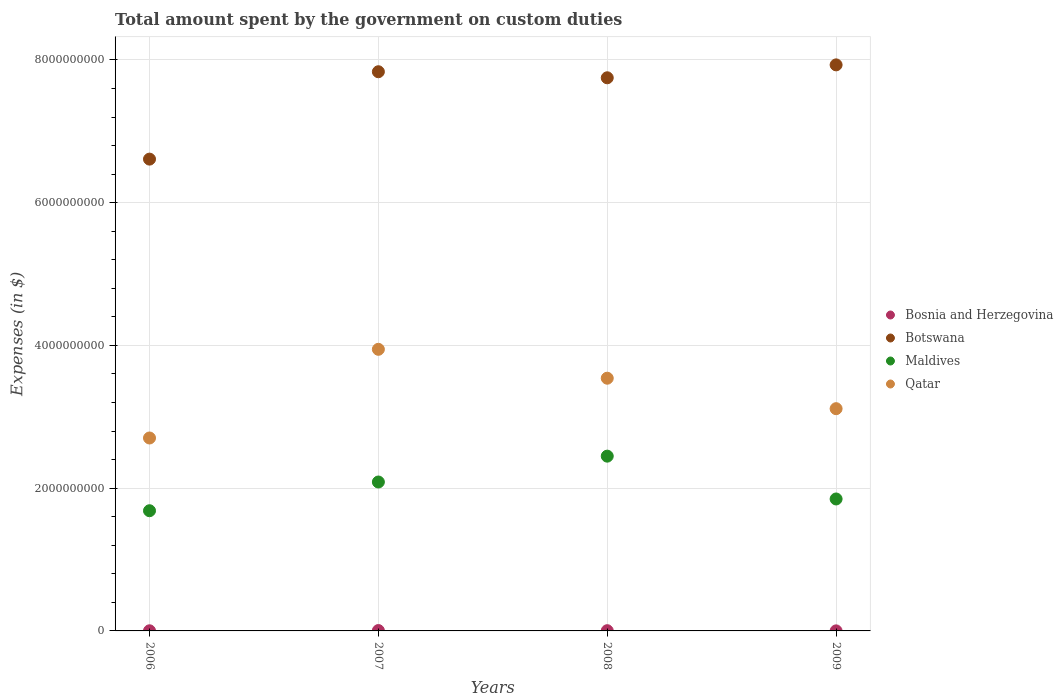Is the number of dotlines equal to the number of legend labels?
Provide a succinct answer. Yes. What is the amount spent on custom duties by the government in Qatar in 2007?
Give a very brief answer. 3.95e+09. Across all years, what is the maximum amount spent on custom duties by the government in Botswana?
Provide a succinct answer. 7.93e+09. Across all years, what is the minimum amount spent on custom duties by the government in Qatar?
Provide a short and direct response. 2.70e+09. What is the total amount spent on custom duties by the government in Qatar in the graph?
Your response must be concise. 1.33e+1. What is the difference between the amount spent on custom duties by the government in Bosnia and Herzegovina in 2006 and that in 2007?
Offer a terse response. -3.30e+06. What is the difference between the amount spent on custom duties by the government in Botswana in 2007 and the amount spent on custom duties by the government in Qatar in 2008?
Provide a short and direct response. 4.29e+09. What is the average amount spent on custom duties by the government in Maldives per year?
Keep it short and to the point. 2.02e+09. In the year 2006, what is the difference between the amount spent on custom duties by the government in Qatar and amount spent on custom duties by the government in Bosnia and Herzegovina?
Offer a terse response. 2.70e+09. What is the ratio of the amount spent on custom duties by the government in Bosnia and Herzegovina in 2006 to that in 2007?
Your answer should be very brief. 0.36. What is the difference between the highest and the second highest amount spent on custom duties by the government in Maldives?
Your answer should be very brief. 3.62e+08. What is the difference between the highest and the lowest amount spent on custom duties by the government in Qatar?
Give a very brief answer. 1.24e+09. Is it the case that in every year, the sum of the amount spent on custom duties by the government in Bosnia and Herzegovina and amount spent on custom duties by the government in Maldives  is greater than the sum of amount spent on custom duties by the government in Botswana and amount spent on custom duties by the government in Qatar?
Keep it short and to the point. Yes. Is the amount spent on custom duties by the government in Botswana strictly less than the amount spent on custom duties by the government in Qatar over the years?
Keep it short and to the point. No. How many dotlines are there?
Keep it short and to the point. 4. How many years are there in the graph?
Your response must be concise. 4. What is the difference between two consecutive major ticks on the Y-axis?
Ensure brevity in your answer.  2.00e+09. Does the graph contain any zero values?
Provide a succinct answer. No. How are the legend labels stacked?
Your answer should be very brief. Vertical. What is the title of the graph?
Ensure brevity in your answer.  Total amount spent by the government on custom duties. Does "Bosnia and Herzegovina" appear as one of the legend labels in the graph?
Your answer should be compact. Yes. What is the label or title of the Y-axis?
Ensure brevity in your answer.  Expenses (in $). What is the Expenses (in $) of Bosnia and Herzegovina in 2006?
Give a very brief answer. 1.86e+06. What is the Expenses (in $) of Botswana in 2006?
Your answer should be very brief. 6.61e+09. What is the Expenses (in $) of Maldives in 2006?
Provide a succinct answer. 1.68e+09. What is the Expenses (in $) of Qatar in 2006?
Your answer should be compact. 2.70e+09. What is the Expenses (in $) in Bosnia and Herzegovina in 2007?
Offer a very short reply. 5.15e+06. What is the Expenses (in $) in Botswana in 2007?
Keep it short and to the point. 7.83e+09. What is the Expenses (in $) in Maldives in 2007?
Offer a terse response. 2.09e+09. What is the Expenses (in $) of Qatar in 2007?
Offer a very short reply. 3.95e+09. What is the Expenses (in $) of Bosnia and Herzegovina in 2008?
Keep it short and to the point. 3.23e+06. What is the Expenses (in $) of Botswana in 2008?
Provide a succinct answer. 7.75e+09. What is the Expenses (in $) in Maldives in 2008?
Make the answer very short. 2.45e+09. What is the Expenses (in $) of Qatar in 2008?
Offer a very short reply. 3.54e+09. What is the Expenses (in $) in Bosnia and Herzegovina in 2009?
Give a very brief answer. 7.27e+05. What is the Expenses (in $) of Botswana in 2009?
Offer a terse response. 7.93e+09. What is the Expenses (in $) in Maldives in 2009?
Your response must be concise. 1.85e+09. What is the Expenses (in $) of Qatar in 2009?
Offer a very short reply. 3.11e+09. Across all years, what is the maximum Expenses (in $) of Bosnia and Herzegovina?
Offer a terse response. 5.15e+06. Across all years, what is the maximum Expenses (in $) of Botswana?
Offer a very short reply. 7.93e+09. Across all years, what is the maximum Expenses (in $) in Maldives?
Provide a succinct answer. 2.45e+09. Across all years, what is the maximum Expenses (in $) of Qatar?
Your response must be concise. 3.95e+09. Across all years, what is the minimum Expenses (in $) in Bosnia and Herzegovina?
Provide a short and direct response. 7.27e+05. Across all years, what is the minimum Expenses (in $) of Botswana?
Provide a short and direct response. 6.61e+09. Across all years, what is the minimum Expenses (in $) of Maldives?
Your answer should be very brief. 1.68e+09. Across all years, what is the minimum Expenses (in $) of Qatar?
Make the answer very short. 2.70e+09. What is the total Expenses (in $) in Bosnia and Herzegovina in the graph?
Offer a terse response. 1.10e+07. What is the total Expenses (in $) of Botswana in the graph?
Keep it short and to the point. 3.01e+1. What is the total Expenses (in $) in Maldives in the graph?
Your answer should be very brief. 8.07e+09. What is the total Expenses (in $) in Qatar in the graph?
Ensure brevity in your answer.  1.33e+1. What is the difference between the Expenses (in $) of Bosnia and Herzegovina in 2006 and that in 2007?
Make the answer very short. -3.30e+06. What is the difference between the Expenses (in $) of Botswana in 2006 and that in 2007?
Keep it short and to the point. -1.22e+09. What is the difference between the Expenses (in $) in Maldives in 2006 and that in 2007?
Your answer should be compact. -4.02e+08. What is the difference between the Expenses (in $) in Qatar in 2006 and that in 2007?
Keep it short and to the point. -1.24e+09. What is the difference between the Expenses (in $) in Bosnia and Herzegovina in 2006 and that in 2008?
Give a very brief answer. -1.38e+06. What is the difference between the Expenses (in $) in Botswana in 2006 and that in 2008?
Make the answer very short. -1.14e+09. What is the difference between the Expenses (in $) of Maldives in 2006 and that in 2008?
Your response must be concise. -7.65e+08. What is the difference between the Expenses (in $) in Qatar in 2006 and that in 2008?
Make the answer very short. -8.38e+08. What is the difference between the Expenses (in $) in Bosnia and Herzegovina in 2006 and that in 2009?
Ensure brevity in your answer.  1.13e+06. What is the difference between the Expenses (in $) in Botswana in 2006 and that in 2009?
Provide a short and direct response. -1.32e+09. What is the difference between the Expenses (in $) in Maldives in 2006 and that in 2009?
Provide a short and direct response. -1.65e+08. What is the difference between the Expenses (in $) in Qatar in 2006 and that in 2009?
Give a very brief answer. -4.11e+08. What is the difference between the Expenses (in $) of Bosnia and Herzegovina in 2007 and that in 2008?
Keep it short and to the point. 1.92e+06. What is the difference between the Expenses (in $) of Botswana in 2007 and that in 2008?
Give a very brief answer. 8.47e+07. What is the difference between the Expenses (in $) of Maldives in 2007 and that in 2008?
Your answer should be very brief. -3.62e+08. What is the difference between the Expenses (in $) in Qatar in 2007 and that in 2008?
Offer a terse response. 4.05e+08. What is the difference between the Expenses (in $) of Bosnia and Herzegovina in 2007 and that in 2009?
Provide a short and direct response. 4.43e+06. What is the difference between the Expenses (in $) of Botswana in 2007 and that in 2009?
Make the answer very short. -9.62e+07. What is the difference between the Expenses (in $) in Maldives in 2007 and that in 2009?
Offer a very short reply. 2.38e+08. What is the difference between the Expenses (in $) in Qatar in 2007 and that in 2009?
Keep it short and to the point. 8.32e+08. What is the difference between the Expenses (in $) in Bosnia and Herzegovina in 2008 and that in 2009?
Your answer should be very brief. 2.51e+06. What is the difference between the Expenses (in $) in Botswana in 2008 and that in 2009?
Your answer should be compact. -1.81e+08. What is the difference between the Expenses (in $) in Maldives in 2008 and that in 2009?
Provide a succinct answer. 6.00e+08. What is the difference between the Expenses (in $) of Qatar in 2008 and that in 2009?
Make the answer very short. 4.27e+08. What is the difference between the Expenses (in $) in Bosnia and Herzegovina in 2006 and the Expenses (in $) in Botswana in 2007?
Your answer should be compact. -7.83e+09. What is the difference between the Expenses (in $) of Bosnia and Herzegovina in 2006 and the Expenses (in $) of Maldives in 2007?
Your answer should be compact. -2.08e+09. What is the difference between the Expenses (in $) of Bosnia and Herzegovina in 2006 and the Expenses (in $) of Qatar in 2007?
Keep it short and to the point. -3.94e+09. What is the difference between the Expenses (in $) in Botswana in 2006 and the Expenses (in $) in Maldives in 2007?
Give a very brief answer. 4.52e+09. What is the difference between the Expenses (in $) of Botswana in 2006 and the Expenses (in $) of Qatar in 2007?
Offer a very short reply. 2.66e+09. What is the difference between the Expenses (in $) of Maldives in 2006 and the Expenses (in $) of Qatar in 2007?
Offer a terse response. -2.26e+09. What is the difference between the Expenses (in $) of Bosnia and Herzegovina in 2006 and the Expenses (in $) of Botswana in 2008?
Provide a short and direct response. -7.75e+09. What is the difference between the Expenses (in $) of Bosnia and Herzegovina in 2006 and the Expenses (in $) of Maldives in 2008?
Your response must be concise. -2.45e+09. What is the difference between the Expenses (in $) in Bosnia and Herzegovina in 2006 and the Expenses (in $) in Qatar in 2008?
Offer a terse response. -3.54e+09. What is the difference between the Expenses (in $) of Botswana in 2006 and the Expenses (in $) of Maldives in 2008?
Your response must be concise. 4.16e+09. What is the difference between the Expenses (in $) of Botswana in 2006 and the Expenses (in $) of Qatar in 2008?
Ensure brevity in your answer.  3.07e+09. What is the difference between the Expenses (in $) in Maldives in 2006 and the Expenses (in $) in Qatar in 2008?
Ensure brevity in your answer.  -1.86e+09. What is the difference between the Expenses (in $) of Bosnia and Herzegovina in 2006 and the Expenses (in $) of Botswana in 2009?
Give a very brief answer. -7.93e+09. What is the difference between the Expenses (in $) of Bosnia and Herzegovina in 2006 and the Expenses (in $) of Maldives in 2009?
Provide a short and direct response. -1.85e+09. What is the difference between the Expenses (in $) of Bosnia and Herzegovina in 2006 and the Expenses (in $) of Qatar in 2009?
Your answer should be compact. -3.11e+09. What is the difference between the Expenses (in $) of Botswana in 2006 and the Expenses (in $) of Maldives in 2009?
Give a very brief answer. 4.76e+09. What is the difference between the Expenses (in $) in Botswana in 2006 and the Expenses (in $) in Qatar in 2009?
Offer a terse response. 3.50e+09. What is the difference between the Expenses (in $) of Maldives in 2006 and the Expenses (in $) of Qatar in 2009?
Your response must be concise. -1.43e+09. What is the difference between the Expenses (in $) in Bosnia and Herzegovina in 2007 and the Expenses (in $) in Botswana in 2008?
Ensure brevity in your answer.  -7.74e+09. What is the difference between the Expenses (in $) in Bosnia and Herzegovina in 2007 and the Expenses (in $) in Maldives in 2008?
Offer a terse response. -2.44e+09. What is the difference between the Expenses (in $) in Bosnia and Herzegovina in 2007 and the Expenses (in $) in Qatar in 2008?
Offer a terse response. -3.54e+09. What is the difference between the Expenses (in $) of Botswana in 2007 and the Expenses (in $) of Maldives in 2008?
Make the answer very short. 5.39e+09. What is the difference between the Expenses (in $) of Botswana in 2007 and the Expenses (in $) of Qatar in 2008?
Make the answer very short. 4.29e+09. What is the difference between the Expenses (in $) of Maldives in 2007 and the Expenses (in $) of Qatar in 2008?
Your response must be concise. -1.45e+09. What is the difference between the Expenses (in $) in Bosnia and Herzegovina in 2007 and the Expenses (in $) in Botswana in 2009?
Your answer should be compact. -7.93e+09. What is the difference between the Expenses (in $) in Bosnia and Herzegovina in 2007 and the Expenses (in $) in Maldives in 2009?
Your answer should be very brief. -1.84e+09. What is the difference between the Expenses (in $) in Bosnia and Herzegovina in 2007 and the Expenses (in $) in Qatar in 2009?
Ensure brevity in your answer.  -3.11e+09. What is the difference between the Expenses (in $) of Botswana in 2007 and the Expenses (in $) of Maldives in 2009?
Give a very brief answer. 5.99e+09. What is the difference between the Expenses (in $) in Botswana in 2007 and the Expenses (in $) in Qatar in 2009?
Your answer should be very brief. 4.72e+09. What is the difference between the Expenses (in $) in Maldives in 2007 and the Expenses (in $) in Qatar in 2009?
Keep it short and to the point. -1.03e+09. What is the difference between the Expenses (in $) in Bosnia and Herzegovina in 2008 and the Expenses (in $) in Botswana in 2009?
Your answer should be compact. -7.93e+09. What is the difference between the Expenses (in $) in Bosnia and Herzegovina in 2008 and the Expenses (in $) in Maldives in 2009?
Your response must be concise. -1.85e+09. What is the difference between the Expenses (in $) in Bosnia and Herzegovina in 2008 and the Expenses (in $) in Qatar in 2009?
Keep it short and to the point. -3.11e+09. What is the difference between the Expenses (in $) in Botswana in 2008 and the Expenses (in $) in Maldives in 2009?
Provide a short and direct response. 5.90e+09. What is the difference between the Expenses (in $) in Botswana in 2008 and the Expenses (in $) in Qatar in 2009?
Keep it short and to the point. 4.64e+09. What is the difference between the Expenses (in $) in Maldives in 2008 and the Expenses (in $) in Qatar in 2009?
Your response must be concise. -6.65e+08. What is the average Expenses (in $) in Bosnia and Herzegovina per year?
Your answer should be very brief. 2.74e+06. What is the average Expenses (in $) in Botswana per year?
Your answer should be compact. 7.53e+09. What is the average Expenses (in $) in Maldives per year?
Provide a succinct answer. 2.02e+09. What is the average Expenses (in $) of Qatar per year?
Ensure brevity in your answer.  3.33e+09. In the year 2006, what is the difference between the Expenses (in $) of Bosnia and Herzegovina and Expenses (in $) of Botswana?
Give a very brief answer. -6.61e+09. In the year 2006, what is the difference between the Expenses (in $) of Bosnia and Herzegovina and Expenses (in $) of Maldives?
Give a very brief answer. -1.68e+09. In the year 2006, what is the difference between the Expenses (in $) in Bosnia and Herzegovina and Expenses (in $) in Qatar?
Ensure brevity in your answer.  -2.70e+09. In the year 2006, what is the difference between the Expenses (in $) in Botswana and Expenses (in $) in Maldives?
Your answer should be very brief. 4.93e+09. In the year 2006, what is the difference between the Expenses (in $) of Botswana and Expenses (in $) of Qatar?
Make the answer very short. 3.91e+09. In the year 2006, what is the difference between the Expenses (in $) of Maldives and Expenses (in $) of Qatar?
Your answer should be very brief. -1.02e+09. In the year 2007, what is the difference between the Expenses (in $) of Bosnia and Herzegovina and Expenses (in $) of Botswana?
Provide a succinct answer. -7.83e+09. In the year 2007, what is the difference between the Expenses (in $) in Bosnia and Herzegovina and Expenses (in $) in Maldives?
Provide a short and direct response. -2.08e+09. In the year 2007, what is the difference between the Expenses (in $) of Bosnia and Herzegovina and Expenses (in $) of Qatar?
Your answer should be very brief. -3.94e+09. In the year 2007, what is the difference between the Expenses (in $) of Botswana and Expenses (in $) of Maldives?
Your answer should be very brief. 5.75e+09. In the year 2007, what is the difference between the Expenses (in $) in Botswana and Expenses (in $) in Qatar?
Your answer should be compact. 3.89e+09. In the year 2007, what is the difference between the Expenses (in $) of Maldives and Expenses (in $) of Qatar?
Give a very brief answer. -1.86e+09. In the year 2008, what is the difference between the Expenses (in $) of Bosnia and Herzegovina and Expenses (in $) of Botswana?
Provide a succinct answer. -7.75e+09. In the year 2008, what is the difference between the Expenses (in $) in Bosnia and Herzegovina and Expenses (in $) in Maldives?
Keep it short and to the point. -2.45e+09. In the year 2008, what is the difference between the Expenses (in $) in Bosnia and Herzegovina and Expenses (in $) in Qatar?
Offer a very short reply. -3.54e+09. In the year 2008, what is the difference between the Expenses (in $) in Botswana and Expenses (in $) in Maldives?
Make the answer very short. 5.30e+09. In the year 2008, what is the difference between the Expenses (in $) of Botswana and Expenses (in $) of Qatar?
Your answer should be very brief. 4.21e+09. In the year 2008, what is the difference between the Expenses (in $) of Maldives and Expenses (in $) of Qatar?
Give a very brief answer. -1.09e+09. In the year 2009, what is the difference between the Expenses (in $) in Bosnia and Herzegovina and Expenses (in $) in Botswana?
Keep it short and to the point. -7.93e+09. In the year 2009, what is the difference between the Expenses (in $) of Bosnia and Herzegovina and Expenses (in $) of Maldives?
Your answer should be very brief. -1.85e+09. In the year 2009, what is the difference between the Expenses (in $) in Bosnia and Herzegovina and Expenses (in $) in Qatar?
Make the answer very short. -3.11e+09. In the year 2009, what is the difference between the Expenses (in $) of Botswana and Expenses (in $) of Maldives?
Provide a succinct answer. 6.08e+09. In the year 2009, what is the difference between the Expenses (in $) of Botswana and Expenses (in $) of Qatar?
Your answer should be compact. 4.82e+09. In the year 2009, what is the difference between the Expenses (in $) in Maldives and Expenses (in $) in Qatar?
Offer a terse response. -1.27e+09. What is the ratio of the Expenses (in $) in Bosnia and Herzegovina in 2006 to that in 2007?
Your answer should be very brief. 0.36. What is the ratio of the Expenses (in $) of Botswana in 2006 to that in 2007?
Offer a very short reply. 0.84. What is the ratio of the Expenses (in $) of Maldives in 2006 to that in 2007?
Provide a succinct answer. 0.81. What is the ratio of the Expenses (in $) of Qatar in 2006 to that in 2007?
Your answer should be compact. 0.69. What is the ratio of the Expenses (in $) of Bosnia and Herzegovina in 2006 to that in 2008?
Your response must be concise. 0.57. What is the ratio of the Expenses (in $) of Botswana in 2006 to that in 2008?
Provide a succinct answer. 0.85. What is the ratio of the Expenses (in $) of Maldives in 2006 to that in 2008?
Your answer should be very brief. 0.69. What is the ratio of the Expenses (in $) in Qatar in 2006 to that in 2008?
Your response must be concise. 0.76. What is the ratio of the Expenses (in $) of Bosnia and Herzegovina in 2006 to that in 2009?
Your response must be concise. 2.55. What is the ratio of the Expenses (in $) in Botswana in 2006 to that in 2009?
Your response must be concise. 0.83. What is the ratio of the Expenses (in $) in Maldives in 2006 to that in 2009?
Your answer should be very brief. 0.91. What is the ratio of the Expenses (in $) of Qatar in 2006 to that in 2009?
Offer a very short reply. 0.87. What is the ratio of the Expenses (in $) in Bosnia and Herzegovina in 2007 to that in 2008?
Offer a very short reply. 1.59. What is the ratio of the Expenses (in $) in Botswana in 2007 to that in 2008?
Your response must be concise. 1.01. What is the ratio of the Expenses (in $) in Maldives in 2007 to that in 2008?
Ensure brevity in your answer.  0.85. What is the ratio of the Expenses (in $) in Qatar in 2007 to that in 2008?
Your response must be concise. 1.11. What is the ratio of the Expenses (in $) of Bosnia and Herzegovina in 2007 to that in 2009?
Your response must be concise. 7.09. What is the ratio of the Expenses (in $) in Botswana in 2007 to that in 2009?
Provide a short and direct response. 0.99. What is the ratio of the Expenses (in $) in Maldives in 2007 to that in 2009?
Keep it short and to the point. 1.13. What is the ratio of the Expenses (in $) of Qatar in 2007 to that in 2009?
Provide a short and direct response. 1.27. What is the ratio of the Expenses (in $) in Bosnia and Herzegovina in 2008 to that in 2009?
Ensure brevity in your answer.  4.45. What is the ratio of the Expenses (in $) of Botswana in 2008 to that in 2009?
Keep it short and to the point. 0.98. What is the ratio of the Expenses (in $) in Maldives in 2008 to that in 2009?
Your answer should be very brief. 1.32. What is the ratio of the Expenses (in $) of Qatar in 2008 to that in 2009?
Ensure brevity in your answer.  1.14. What is the difference between the highest and the second highest Expenses (in $) of Bosnia and Herzegovina?
Your answer should be compact. 1.92e+06. What is the difference between the highest and the second highest Expenses (in $) in Botswana?
Your response must be concise. 9.62e+07. What is the difference between the highest and the second highest Expenses (in $) in Maldives?
Your response must be concise. 3.62e+08. What is the difference between the highest and the second highest Expenses (in $) in Qatar?
Ensure brevity in your answer.  4.05e+08. What is the difference between the highest and the lowest Expenses (in $) in Bosnia and Herzegovina?
Your answer should be compact. 4.43e+06. What is the difference between the highest and the lowest Expenses (in $) of Botswana?
Your response must be concise. 1.32e+09. What is the difference between the highest and the lowest Expenses (in $) of Maldives?
Give a very brief answer. 7.65e+08. What is the difference between the highest and the lowest Expenses (in $) in Qatar?
Offer a very short reply. 1.24e+09. 